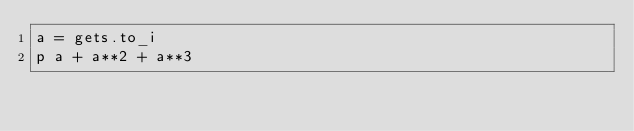Convert code to text. <code><loc_0><loc_0><loc_500><loc_500><_Ruby_>a = gets.to_i
p a + a**2 + a**3</code> 